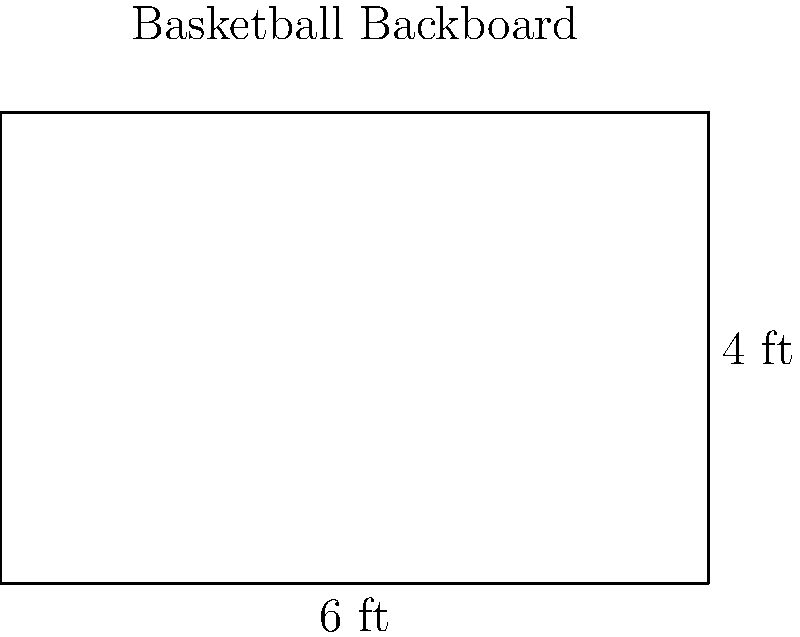A rectangular basketball backboard measures 6 feet in width and 4 feet in height. What is the perimeter of the backboard in feet? To find the perimeter of a rectangle, we need to add up the lengths of all four sides. Let's break it down step-by-step:

1. Identify the dimensions:
   - Width = 6 feet
   - Height = 4 feet

2. The perimeter formula for a rectangle is:
   $P = 2l + 2w$, where $P$ is the perimeter, $l$ is the length (height in this case), and $w$ is the width.

3. Plug in the values:
   $P = 2(4) + 2(6)$

4. Simplify:
   $P = 8 + 12$

5. Calculate the final result:
   $P = 20$

Therefore, the perimeter of the basketball backboard is 20 feet.
Answer: 20 feet 